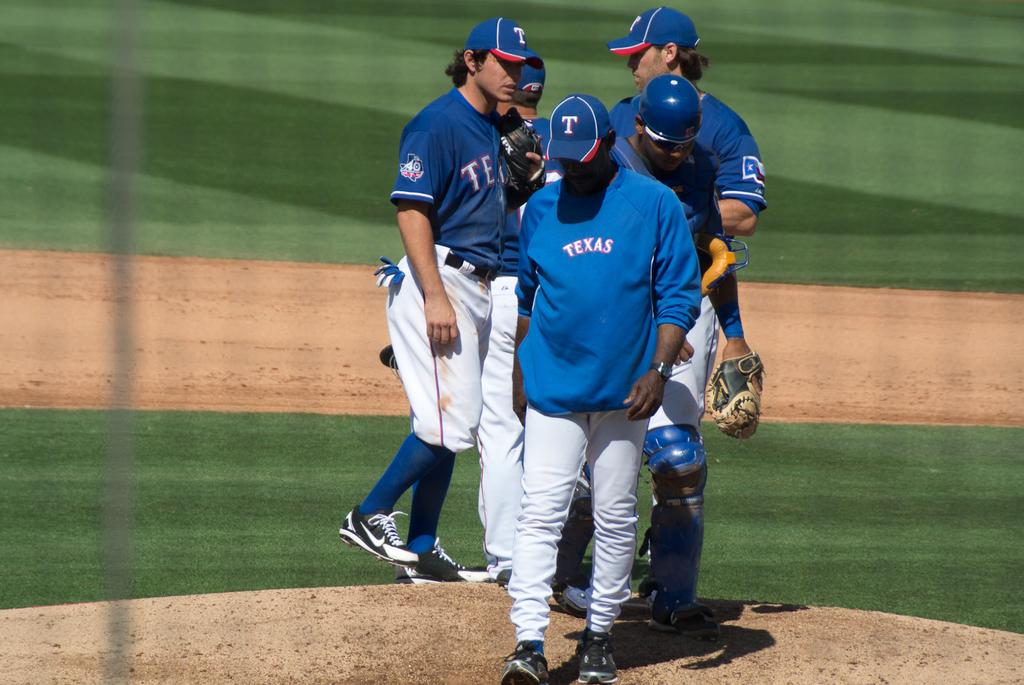<image>
Present a compact description of the photo's key features. Five baseball players stand on the field their shirts say Texas 